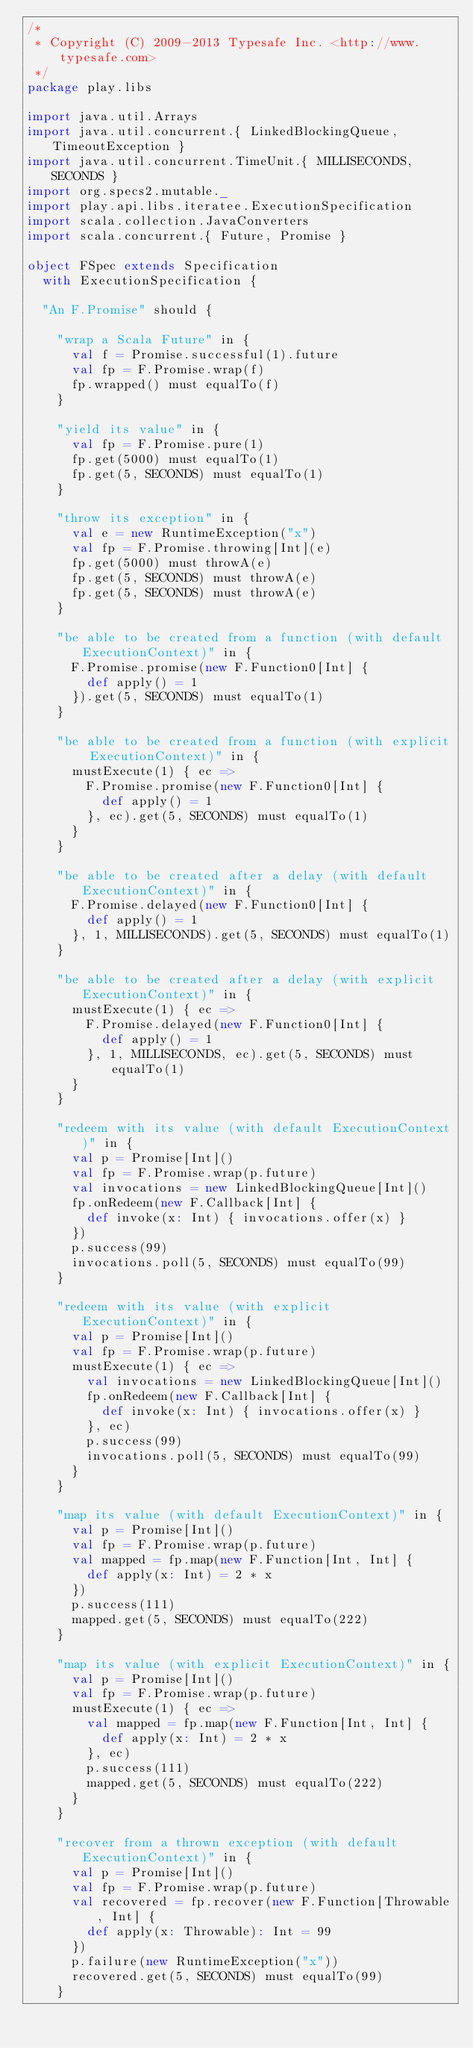<code> <loc_0><loc_0><loc_500><loc_500><_Scala_>/*
 * Copyright (C) 2009-2013 Typesafe Inc. <http://www.typesafe.com>
 */
package play.libs

import java.util.Arrays
import java.util.concurrent.{ LinkedBlockingQueue, TimeoutException }
import java.util.concurrent.TimeUnit.{ MILLISECONDS, SECONDS }
import org.specs2.mutable._
import play.api.libs.iteratee.ExecutionSpecification
import scala.collection.JavaConverters
import scala.concurrent.{ Future, Promise }

object FSpec extends Specification
  with ExecutionSpecification {

  "An F.Promise" should {

    "wrap a Scala Future" in {
      val f = Promise.successful(1).future
      val fp = F.Promise.wrap(f)
      fp.wrapped() must equalTo(f)
    }

    "yield its value" in {
      val fp = F.Promise.pure(1)
      fp.get(5000) must equalTo(1)
      fp.get(5, SECONDS) must equalTo(1)
    }

    "throw its exception" in {
      val e = new RuntimeException("x")
      val fp = F.Promise.throwing[Int](e)
      fp.get(5000) must throwA(e)
      fp.get(5, SECONDS) must throwA(e)
      fp.get(5, SECONDS) must throwA(e)
    }

    "be able to be created from a function (with default ExecutionContext)" in {
      F.Promise.promise(new F.Function0[Int] {
        def apply() = 1
      }).get(5, SECONDS) must equalTo(1)
    }

    "be able to be created from a function (with explicit ExecutionContext)" in {
      mustExecute(1) { ec =>
        F.Promise.promise(new F.Function0[Int] {
          def apply() = 1
        }, ec).get(5, SECONDS) must equalTo(1)
      }
    }

    "be able to be created after a delay (with default ExecutionContext)" in {
      F.Promise.delayed(new F.Function0[Int] {
        def apply() = 1
      }, 1, MILLISECONDS).get(5, SECONDS) must equalTo(1)
    }

    "be able to be created after a delay (with explicit ExecutionContext)" in {
      mustExecute(1) { ec =>
        F.Promise.delayed(new F.Function0[Int] {
          def apply() = 1
        }, 1, MILLISECONDS, ec).get(5, SECONDS) must equalTo(1)
      }
    }

    "redeem with its value (with default ExecutionContext)" in {
      val p = Promise[Int]()
      val fp = F.Promise.wrap(p.future)
      val invocations = new LinkedBlockingQueue[Int]()
      fp.onRedeem(new F.Callback[Int] {
        def invoke(x: Int) { invocations.offer(x) }
      })
      p.success(99)
      invocations.poll(5, SECONDS) must equalTo(99)
    }

    "redeem with its value (with explicit ExecutionContext)" in {
      val p = Promise[Int]()
      val fp = F.Promise.wrap(p.future)
      mustExecute(1) { ec =>
        val invocations = new LinkedBlockingQueue[Int]()
        fp.onRedeem(new F.Callback[Int] {
          def invoke(x: Int) { invocations.offer(x) }
        }, ec)
        p.success(99)
        invocations.poll(5, SECONDS) must equalTo(99)
      }
    }

    "map its value (with default ExecutionContext)" in {
      val p = Promise[Int]()
      val fp = F.Promise.wrap(p.future)
      val mapped = fp.map(new F.Function[Int, Int] {
        def apply(x: Int) = 2 * x
      })
      p.success(111)
      mapped.get(5, SECONDS) must equalTo(222)
    }

    "map its value (with explicit ExecutionContext)" in {
      val p = Promise[Int]()
      val fp = F.Promise.wrap(p.future)
      mustExecute(1) { ec =>
        val mapped = fp.map(new F.Function[Int, Int] {
          def apply(x: Int) = 2 * x
        }, ec)
        p.success(111)
        mapped.get(5, SECONDS) must equalTo(222)
      }
    }

    "recover from a thrown exception (with default ExecutionContext)" in {
      val p = Promise[Int]()
      val fp = F.Promise.wrap(p.future)
      val recovered = fp.recover(new F.Function[Throwable, Int] {
        def apply(x: Throwable): Int = 99
      })
      p.failure(new RuntimeException("x"))
      recovered.get(5, SECONDS) must equalTo(99)
    }
</code> 